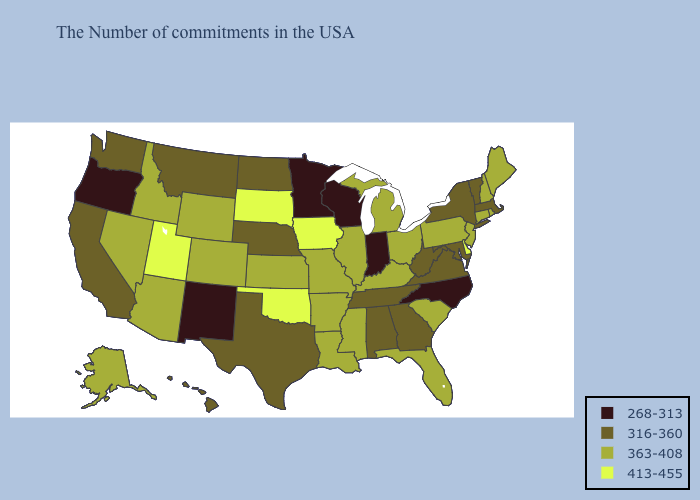Name the states that have a value in the range 363-408?
Be succinct. Maine, Rhode Island, New Hampshire, Connecticut, New Jersey, Pennsylvania, South Carolina, Ohio, Florida, Michigan, Kentucky, Illinois, Mississippi, Louisiana, Missouri, Arkansas, Kansas, Wyoming, Colorado, Arizona, Idaho, Nevada, Alaska. What is the lowest value in the West?
Keep it brief. 268-313. Does Maryland have the highest value in the South?
Quick response, please. No. What is the value of Utah?
Concise answer only. 413-455. Does the map have missing data?
Write a very short answer. No. Name the states that have a value in the range 413-455?
Answer briefly. Delaware, Iowa, Oklahoma, South Dakota, Utah. What is the value of Rhode Island?
Be succinct. 363-408. Name the states that have a value in the range 363-408?
Give a very brief answer. Maine, Rhode Island, New Hampshire, Connecticut, New Jersey, Pennsylvania, South Carolina, Ohio, Florida, Michigan, Kentucky, Illinois, Mississippi, Louisiana, Missouri, Arkansas, Kansas, Wyoming, Colorado, Arizona, Idaho, Nevada, Alaska. What is the highest value in the South ?
Answer briefly. 413-455. Does Iowa have a lower value than Idaho?
Short answer required. No. What is the highest value in the MidWest ?
Be succinct. 413-455. Name the states that have a value in the range 363-408?
Concise answer only. Maine, Rhode Island, New Hampshire, Connecticut, New Jersey, Pennsylvania, South Carolina, Ohio, Florida, Michigan, Kentucky, Illinois, Mississippi, Louisiana, Missouri, Arkansas, Kansas, Wyoming, Colorado, Arizona, Idaho, Nevada, Alaska. Does Wisconsin have a higher value than North Carolina?
Concise answer only. No. What is the value of Colorado?
Concise answer only. 363-408. Name the states that have a value in the range 316-360?
Write a very short answer. Massachusetts, Vermont, New York, Maryland, Virginia, West Virginia, Georgia, Alabama, Tennessee, Nebraska, Texas, North Dakota, Montana, California, Washington, Hawaii. 